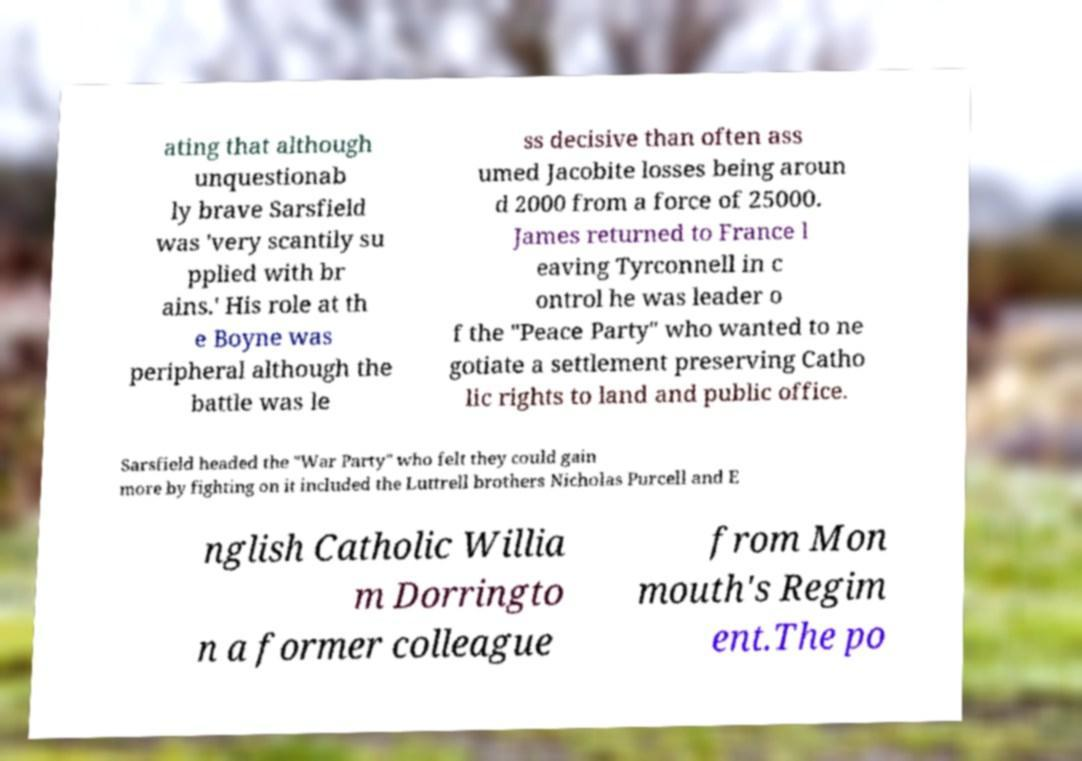I need the written content from this picture converted into text. Can you do that? ating that although unquestionab ly brave Sarsfield was 'very scantily su pplied with br ains.' His role at th e Boyne was peripheral although the battle was le ss decisive than often ass umed Jacobite losses being aroun d 2000 from a force of 25000. James returned to France l eaving Tyrconnell in c ontrol he was leader o f the "Peace Party" who wanted to ne gotiate a settlement preserving Catho lic rights to land and public office. Sarsfield headed the "War Party" who felt they could gain more by fighting on it included the Luttrell brothers Nicholas Purcell and E nglish Catholic Willia m Dorringto n a former colleague from Mon mouth's Regim ent.The po 